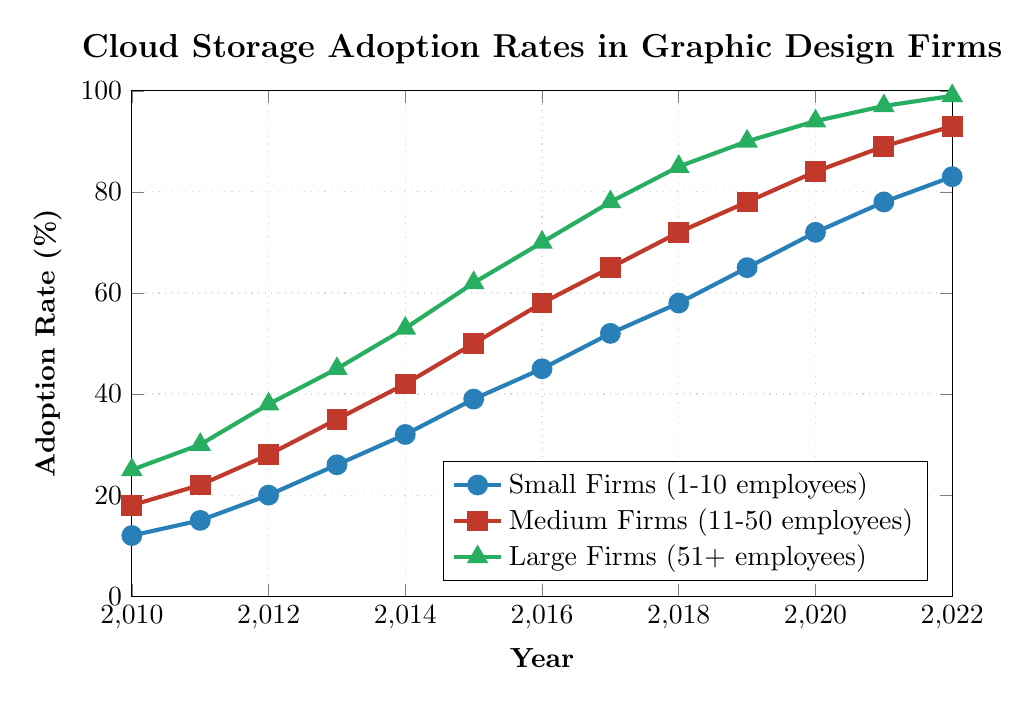Which type of firm had the highest cloud storage adoption rate in 2022? The adoption rate for Small Firms was the lowest at 83%, Medium Firms was higher at 93%, and Large Firms had the highest at 99%.
Answer: Large Firms How did the adoption rate for Medium Firms change from 2014 to 2016? In 2014, the rate for Medium Firms was 42%, and by 2016, it increased to 58%. The change is 58% - 42% = 16%.
Answer: 16% Which firm category saw the largest increase in cloud storage adoption between 2010 and 2022? Small Firms increased from 12% to 83%, so 83% - 12% = 71%. Medium Firms increased from 18% to 93%, so 93% - 18% = 75%. Large Firms increased from 25% to 99%, so 99% - 25% = 74%. Therefore, Medium Firms had the largest increase with 75%.
Answer: Medium Firms In which year did Small Firms overtake a 50% adoption rate? Observing the plot, Small Firms crossed the 50% mark in the year 2017, increasing from 45% in 2016 to 52% in 2017.
Answer: 2017 What was the difference in adoption rates between Medium Firms and Large Firms in 2019? The adoption rate for Medium Firms in 2019 was 78%, while for Large Firms it was 90%. The difference is 90% - 78% = 12%.
Answer: 12% Compare the adoption trends for Small Firms and Large Firms between 2010 and 2014. In 2010, Small Firms had an adoption rate of 12% and Large Firms 25%. By 2014, Small Firms were at 32% and Large Firms at 53%. Both increased, but Large Firms consistently had higher rates.
Answer: Large Firms consistently higher What is the average adoption rate for Medium Firms over the 12 years shown? Summing the adoption rates for Medium Firms from 2010 to 2022 (18, 22, 28, 35, 42, 50, 58, 65, 72, 78, 84, 89, 93) gives 736. The average over 13 years is 736 / 13 ≈ 56.62%.
Answer: 56.62% At what rate did Large Firms adopt cloud storage in 2011 compared to Small Firms? In 2011, Large Firms had an adoption rate of 30%, and Small Firms had a rate of 15%. Large Firms adopted at double the rate compared to Small Firms.
Answer: Double the rate What is the color used to represent Medium Firms on the chart? The plot line for Medium Firms is represented in red.
Answer: Red 